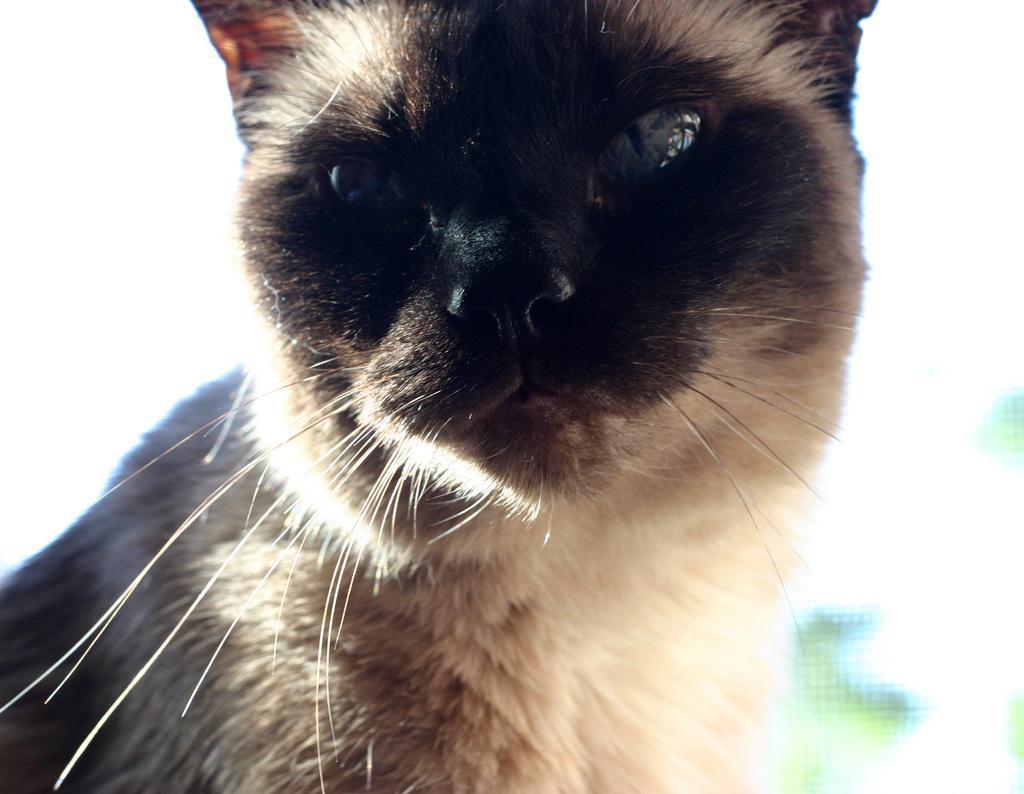Please provide a concise description of this image. In this image we can see a cat and the background is blurry. 